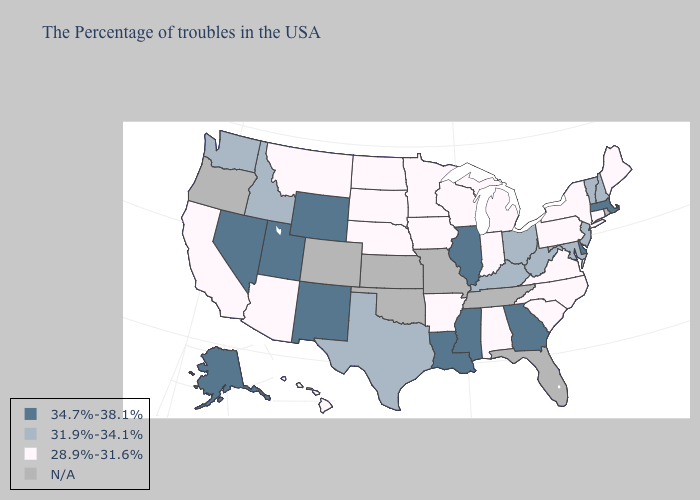What is the lowest value in the Northeast?
Short answer required. 28.9%-31.6%. Name the states that have a value in the range 34.7%-38.1%?
Keep it brief. Massachusetts, Delaware, Georgia, Illinois, Mississippi, Louisiana, Wyoming, New Mexico, Utah, Nevada, Alaska. Among the states that border Arkansas , which have the highest value?
Quick response, please. Mississippi, Louisiana. Does Alaska have the lowest value in the West?
Concise answer only. No. What is the value of North Dakota?
Keep it brief. 28.9%-31.6%. Which states hav the highest value in the MidWest?
Concise answer only. Illinois. What is the value of Maine?
Answer briefly. 28.9%-31.6%. Name the states that have a value in the range N/A?
Answer briefly. Rhode Island, Florida, Tennessee, Missouri, Kansas, Oklahoma, Colorado, Oregon. What is the value of Indiana?
Quick response, please. 28.9%-31.6%. Does the map have missing data?
Concise answer only. Yes. What is the value of Illinois?
Write a very short answer. 34.7%-38.1%. What is the lowest value in the USA?
Answer briefly. 28.9%-31.6%. Name the states that have a value in the range 34.7%-38.1%?
Be succinct. Massachusetts, Delaware, Georgia, Illinois, Mississippi, Louisiana, Wyoming, New Mexico, Utah, Nevada, Alaska. Does the map have missing data?
Write a very short answer. Yes. 